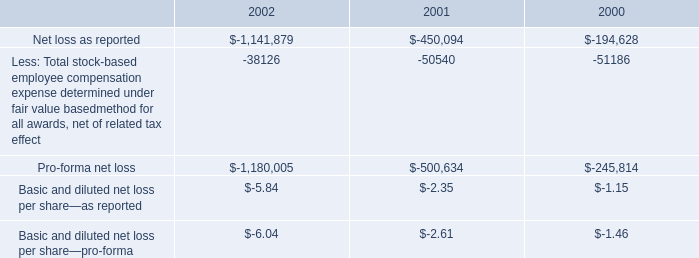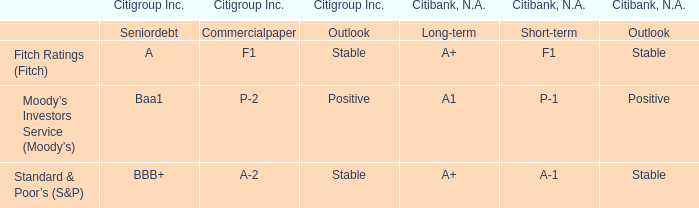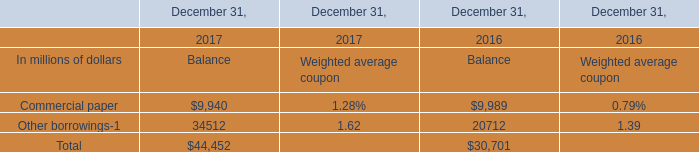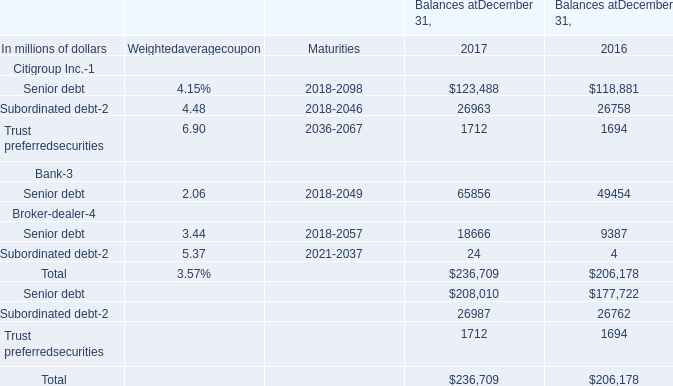What was the average value of Commercial paper, Other borrowings, Total in 2016 for Balance? (in million) 
Computations: (((9989 + 20712) + 30701) / 3)
Answer: 20467.33333. 